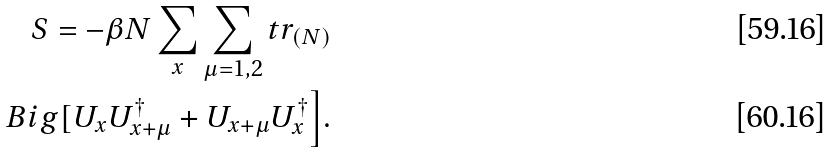Convert formula to latex. <formula><loc_0><loc_0><loc_500><loc_500>S = - \beta N \sum _ { x } \sum _ { \mu = 1 , 2 } t r _ { ( N ) } \\ B i g [ U _ { x } U ^ { \dag } _ { x + \mu } + U _ { x + \mu } U ^ { \dag } _ { x } \Big ] .</formula> 